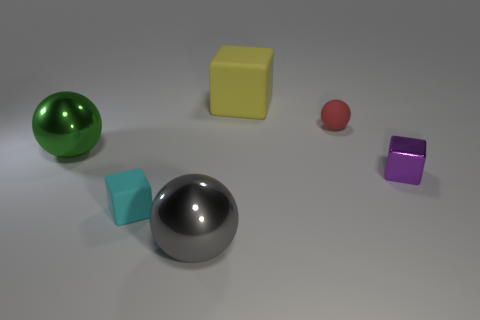What material is the big ball that is left of the cyan rubber object? metal 